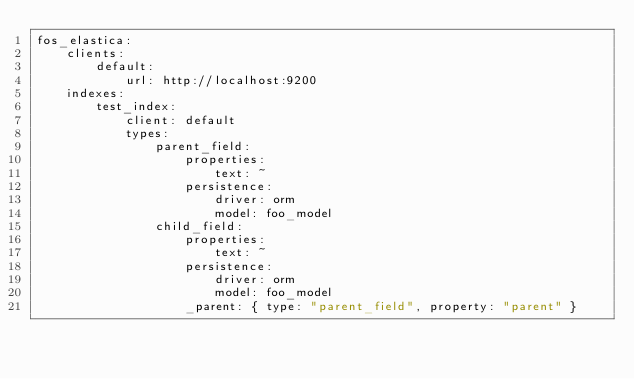Convert code to text. <code><loc_0><loc_0><loc_500><loc_500><_YAML_>fos_elastica:
    clients:
        default:
            url: http://localhost:9200
    indexes:
        test_index:
            client: default
            types:
                parent_field:
                    properties:
                        text: ~
                    persistence:
                        driver: orm
                        model: foo_model
                child_field:
                    properties:
                        text: ~
                    persistence:
                        driver: orm
                        model: foo_model
                    _parent: { type: "parent_field", property: "parent" }
</code> 